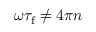<formula> <loc_0><loc_0><loc_500><loc_500>\omega \tau _ { f } \neq 4 \pi n</formula> 